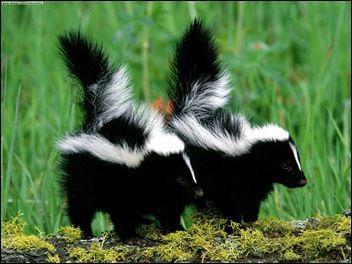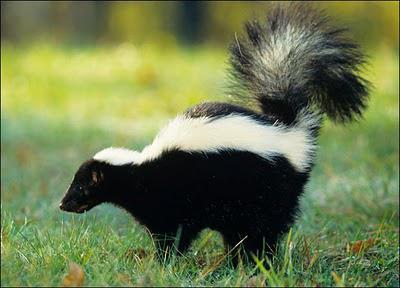The first image is the image on the left, the second image is the image on the right. Examine the images to the left and right. Is the description "In at least one image there is a single skunk facing left." accurate? Answer yes or no. Yes. The first image is the image on the left, the second image is the image on the right. Examine the images to the left and right. Is the description "There is a single skunk in the right image." accurate? Answer yes or no. Yes. 